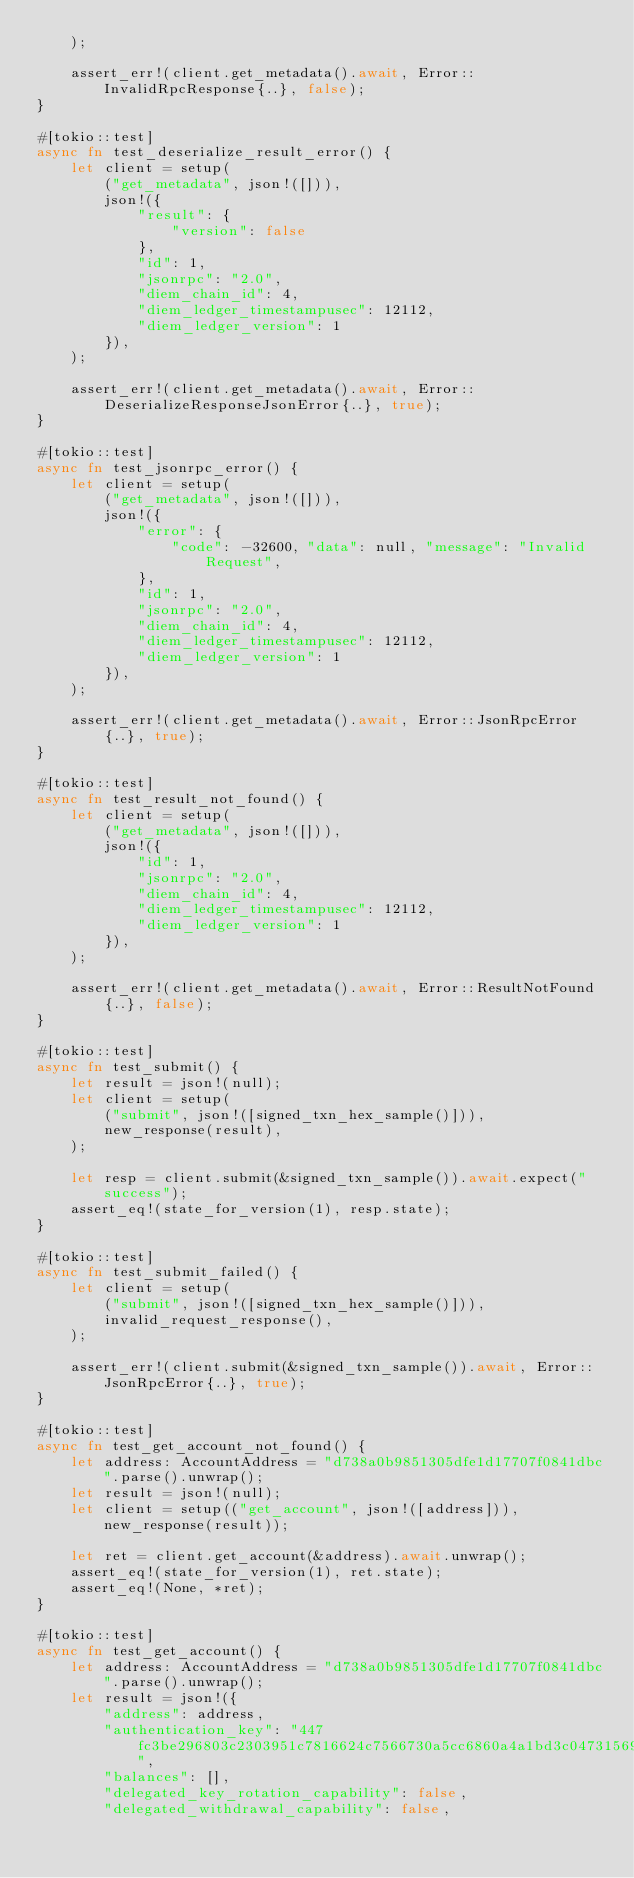Convert code to text. <code><loc_0><loc_0><loc_500><loc_500><_Rust_>    );

    assert_err!(client.get_metadata().await, Error::InvalidRpcResponse{..}, false);
}

#[tokio::test]
async fn test_deserialize_result_error() {
    let client = setup(
        ("get_metadata", json!([])),
        json!({
            "result": {
                "version": false
            },
            "id": 1,
            "jsonrpc": "2.0",
            "diem_chain_id": 4,
            "diem_ledger_timestampusec": 12112,
            "diem_ledger_version": 1
        }),
    );

    assert_err!(client.get_metadata().await, Error::DeserializeResponseJsonError{..}, true);
}

#[tokio::test]
async fn test_jsonrpc_error() {
    let client = setup(
        ("get_metadata", json!([])),
        json!({
            "error": {
                "code": -32600, "data": null, "message": "Invalid Request",
            },
            "id": 1,
            "jsonrpc": "2.0",
            "diem_chain_id": 4,
            "diem_ledger_timestampusec": 12112,
            "diem_ledger_version": 1
        }),
    );

    assert_err!(client.get_metadata().await, Error::JsonRpcError{..}, true);
}

#[tokio::test]
async fn test_result_not_found() {
    let client = setup(
        ("get_metadata", json!([])),
        json!({
            "id": 1,
            "jsonrpc": "2.0",
            "diem_chain_id": 4,
            "diem_ledger_timestampusec": 12112,
            "diem_ledger_version": 1
        }),
    );

    assert_err!(client.get_metadata().await, Error::ResultNotFound{..}, false);
}

#[tokio::test]
async fn test_submit() {
    let result = json!(null);
    let client = setup(
        ("submit", json!([signed_txn_hex_sample()])),
        new_response(result),
    );

    let resp = client.submit(&signed_txn_sample()).await.expect("success");
    assert_eq!(state_for_version(1), resp.state);
}

#[tokio::test]
async fn test_submit_failed() {
    let client = setup(
        ("submit", json!([signed_txn_hex_sample()])),
        invalid_request_response(),
    );

    assert_err!(client.submit(&signed_txn_sample()).await, Error::JsonRpcError{..}, true);
}

#[tokio::test]
async fn test_get_account_not_found() {
    let address: AccountAddress = "d738a0b9851305dfe1d17707f0841dbc".parse().unwrap();
    let result = json!(null);
    let client = setup(("get_account", json!([address])), new_response(result));

    let ret = client.get_account(&address).await.unwrap();
    assert_eq!(state_for_version(1), ret.state);
    assert_eq!(None, *ret);
}

#[tokio::test]
async fn test_get_account() {
    let address: AccountAddress = "d738a0b9851305dfe1d17707f0841dbc".parse().unwrap();
    let result = json!({
        "address": address,
        "authentication_key": "447fc3be296803c2303951c7816624c7566730a5cc6860a4a1bd3c04731569f5",
        "balances": [],
        "delegated_key_rotation_capability": false,
        "delegated_withdrawal_capability": false,</code> 